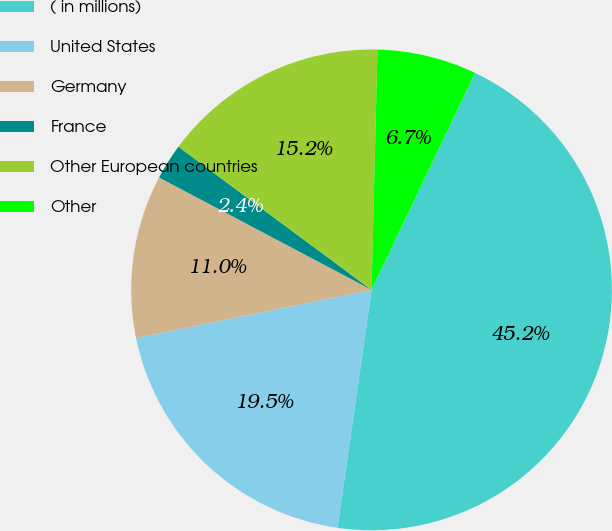Convert chart to OTSL. <chart><loc_0><loc_0><loc_500><loc_500><pie_chart><fcel>( in millions)<fcel>United States<fcel>Germany<fcel>France<fcel>Other European countries<fcel>Other<nl><fcel>45.18%<fcel>19.52%<fcel>10.96%<fcel>2.41%<fcel>15.24%<fcel>6.69%<nl></chart> 